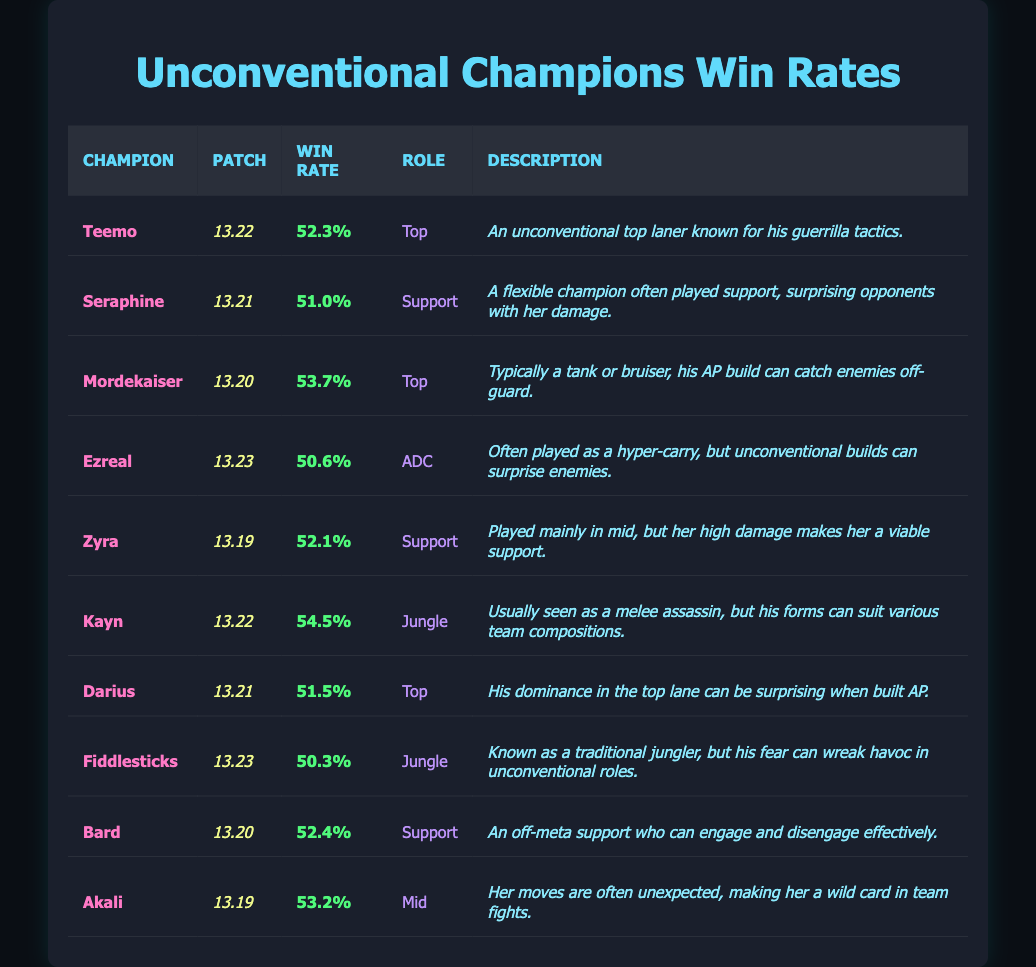What is the highest win rate among the listed champions? Scanning the win rates, Kayn has the highest win rate at 54.5% in patch 13.22.
Answer: 54.5% Which champion was played as a support and has a 51.0% win rate? Looking for the champion with a role of Support and matching the win rate of 51.0%, it is Seraphine in patch 13.21.
Answer: Seraphine How many champions have a win rate above 52%? The champions with win rates above 52% are Teemo (52.3%), Mordekaiser (53.7%), Kayn (54.5%), Bard (52.4%), and Akali (53.2%). This gives us a total of 5 champions.
Answer: 5 Is Zyra played in the ADC role? Zyra is listed as a Support, not in the ADC role. Therefore, the statement is false.
Answer: No What is the average win rate of the top lane champions in the table? The champions in the Top role are Teemo (52.3%), Mordekaiser (53.7%), and Darius (51.5%). The average is calculated as (52.3 + 53.7 + 51.5) / 3 = 52.5%.
Answer: 52.5% Which champion has a lower win rate, Fiddlesticks or Ezreal? Fiddlesticks has a win rate of 50.3% and Ezreal has 50.6%. Since 50.3% is lower, the answer is Fiddlesticks.
Answer: Fiddlesticks How many champions have win rates in the 50% range? The champions with win rates below 52% but above 50% are Seraphine (51.0%), Ezreal (50.6%), Darius (51.5%), and Fiddlesticks (50.3%). This totals to 4 champions.
Answer: 4 Which patch has the most champions listed, and how many champions are in that patch? The patches 13.22 and 13.21 each have 2 champions listed, while others have either 1 or 0. So, patches 13.22 and 13.21 are the most populated.
Answer: 2 champions (patches 13.22 and 13.21) Is Akali an unconventional champion? Based on her description, Akali utilizes unexpected moves in team fights, indicating she is unconventional, making the statement true.
Answer: Yes What role does Kayn play, and what is his win rate? Kayn is listed as a Jungle player with a win rate of 54.5%.
Answer: Jungle, 54.5% 